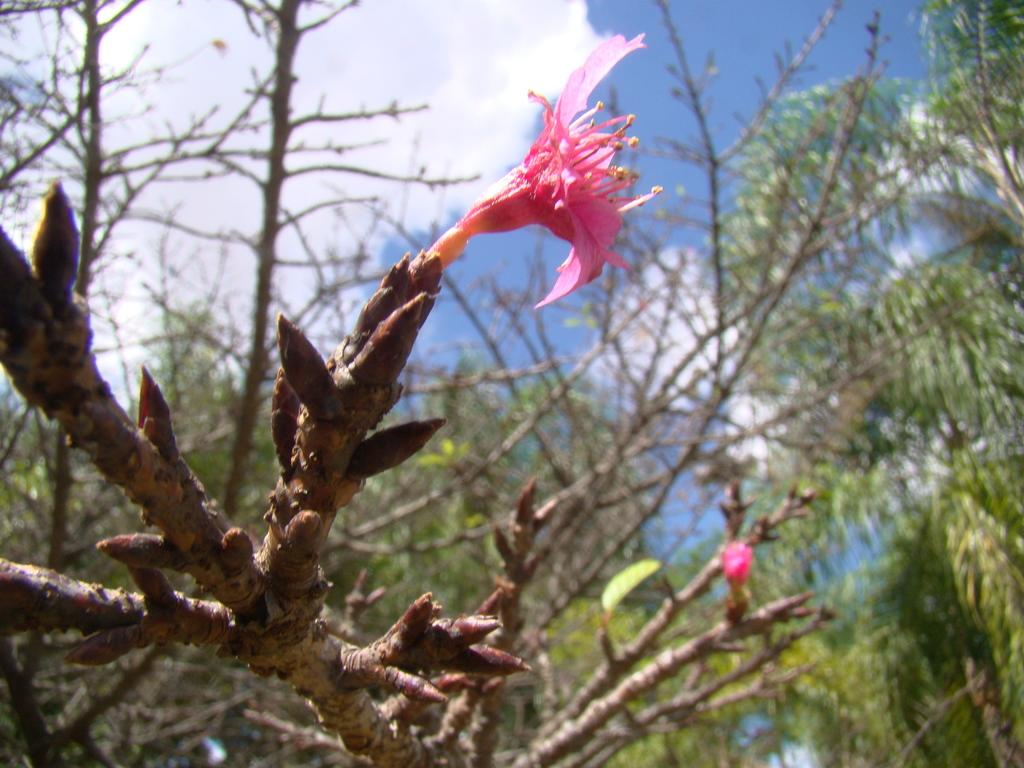What type of plant is depicted in the image? There is a flower and a bud in the image, which suggests that it is a plant. What parts of the plant can be seen in the image? There are branches, stems, and leaves of trees visible in the image. What is visible in the background of the image? The sky is visible in the background of the image. What type of chair is placed next to the plant in the image? There is no chair present in the image; it only features a plant with various parts visible. Can you read the letter that is lying on the ground near the plant in the image? There is no letter present in the image; it only features a plant with various parts visible. 